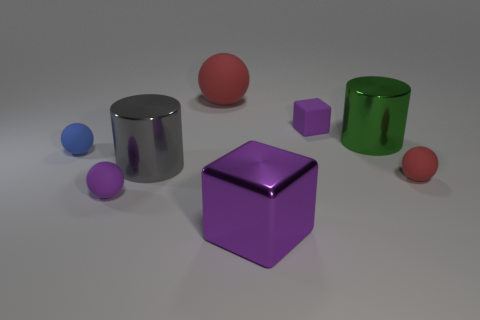What shape is the big purple thing that is to the left of the tiny red rubber sphere?
Provide a short and direct response. Cube. What material is the big thing that is the same shape as the tiny blue object?
Offer a terse response. Rubber. Does the purple object that is behind the blue object have the same size as the green metallic cylinder?
Your response must be concise. No. There is a large green shiny cylinder; what number of large cubes are behind it?
Keep it short and to the point. 0. Is the number of red objects that are on the left side of the big gray cylinder less than the number of big green things on the left side of the small purple block?
Provide a succinct answer. No. What number of tiny purple things are there?
Your answer should be very brief. 2. The tiny rubber thing to the right of the large green cylinder is what color?
Keep it short and to the point. Red. How big is the purple metal cube?
Provide a short and direct response. Large. There is a big sphere; does it have the same color as the shiny cylinder behind the small blue rubber thing?
Your answer should be very brief. No. The large shiny cylinder right of the purple cube that is right of the big purple metal block is what color?
Offer a very short reply. Green. 